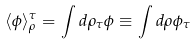<formula> <loc_0><loc_0><loc_500><loc_500>\langle \phi \rangle ^ { \tau } _ { \rho } = \int d \rho _ { \tau } \phi \equiv \int d \rho \phi _ { \tau }</formula> 